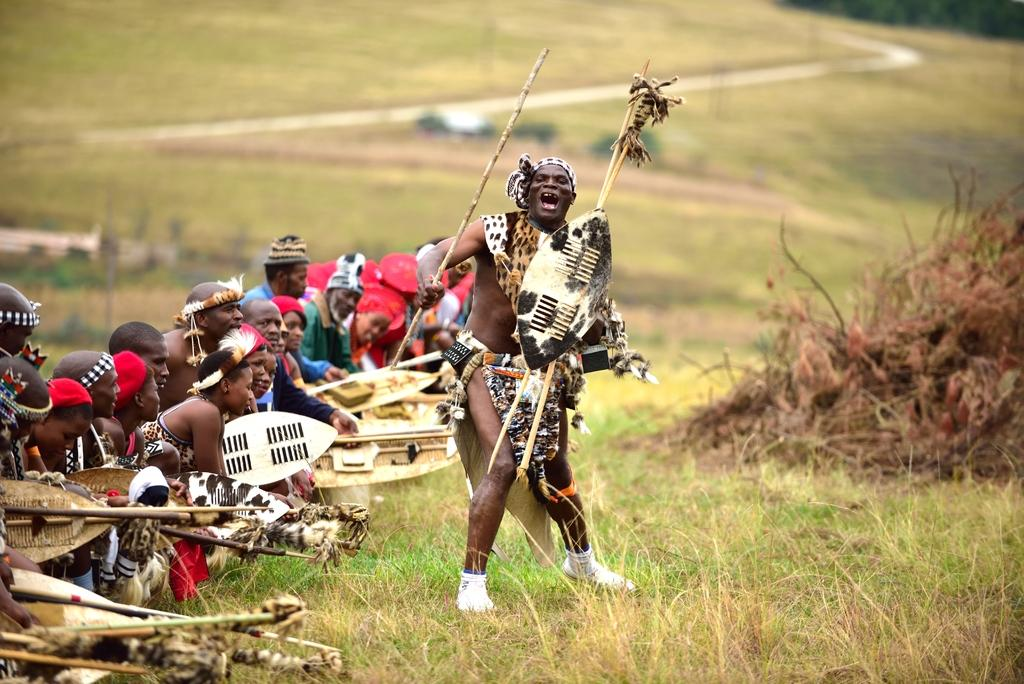What is the main subject of the image? The main subject of the image is a man standing in the middle. What is the man doing in the image? The man is performing different actions in the image. Who else is present in the image? There is a group of persons on the left side of the image. What is the group of persons doing? The group of persons is observing the man. What type of ground is visible in the image? There is grass at the bottom of the image. Can you tell me how many toes the man has in the image? There is no information about the man's toes in the image, so it cannot be determined. What type of park or trail can be seen in the image? There is no park or trail present in the image; it features a man performing actions and a group of persons observing him on a grassy area. 